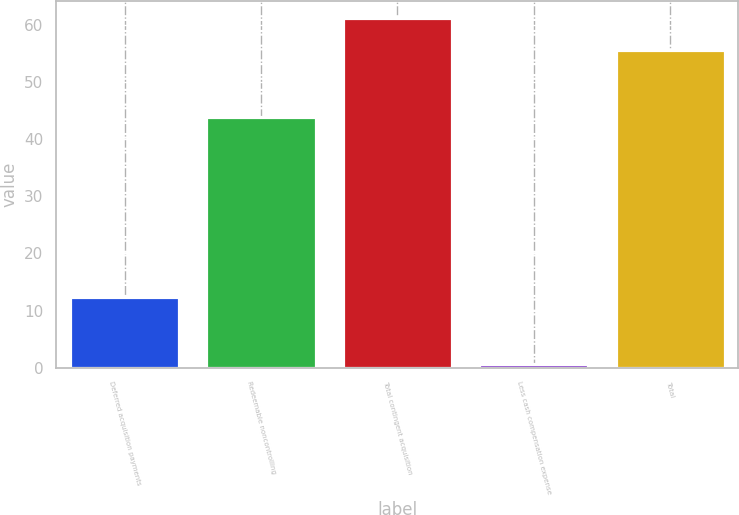<chart> <loc_0><loc_0><loc_500><loc_500><bar_chart><fcel>Deferred acquisition payments<fcel>Redeemable noncontrolling<fcel>Total contingent acquisition<fcel>Less cash compensation expense<fcel>Total<nl><fcel>12.4<fcel>43.8<fcel>61.16<fcel>0.6<fcel>55.6<nl></chart> 